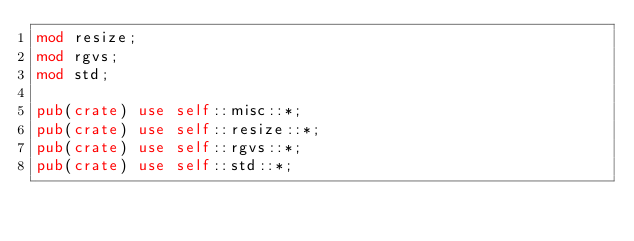<code> <loc_0><loc_0><loc_500><loc_500><_Rust_>mod resize;
mod rgvs;
mod std;

pub(crate) use self::misc::*;
pub(crate) use self::resize::*;
pub(crate) use self::rgvs::*;
pub(crate) use self::std::*;
</code> 